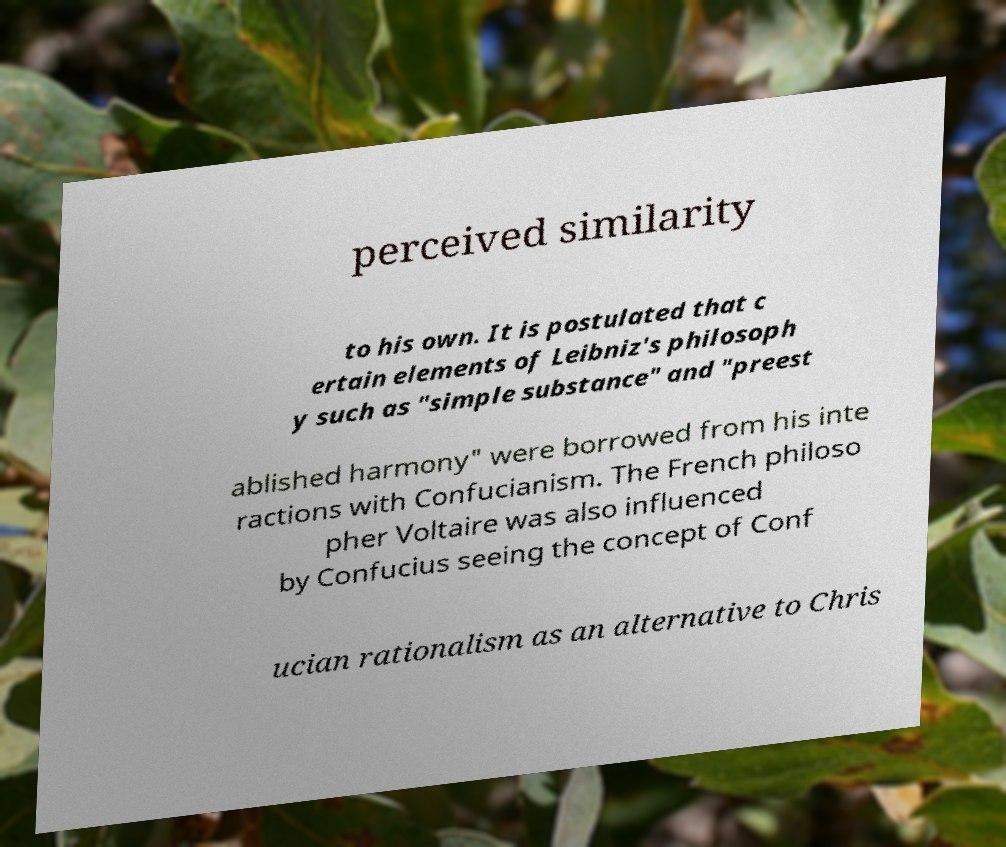Could you assist in decoding the text presented in this image and type it out clearly? perceived similarity to his own. It is postulated that c ertain elements of Leibniz's philosoph y such as "simple substance" and "preest ablished harmony" were borrowed from his inte ractions with Confucianism. The French philoso pher Voltaire was also influenced by Confucius seeing the concept of Conf ucian rationalism as an alternative to Chris 